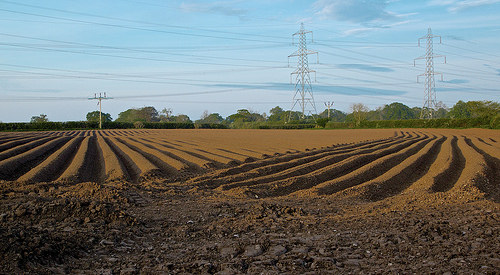<image>
Can you confirm if the land is on the sand? No. The land is not positioned on the sand. They may be near each other, but the land is not supported by or resting on top of the sand. 